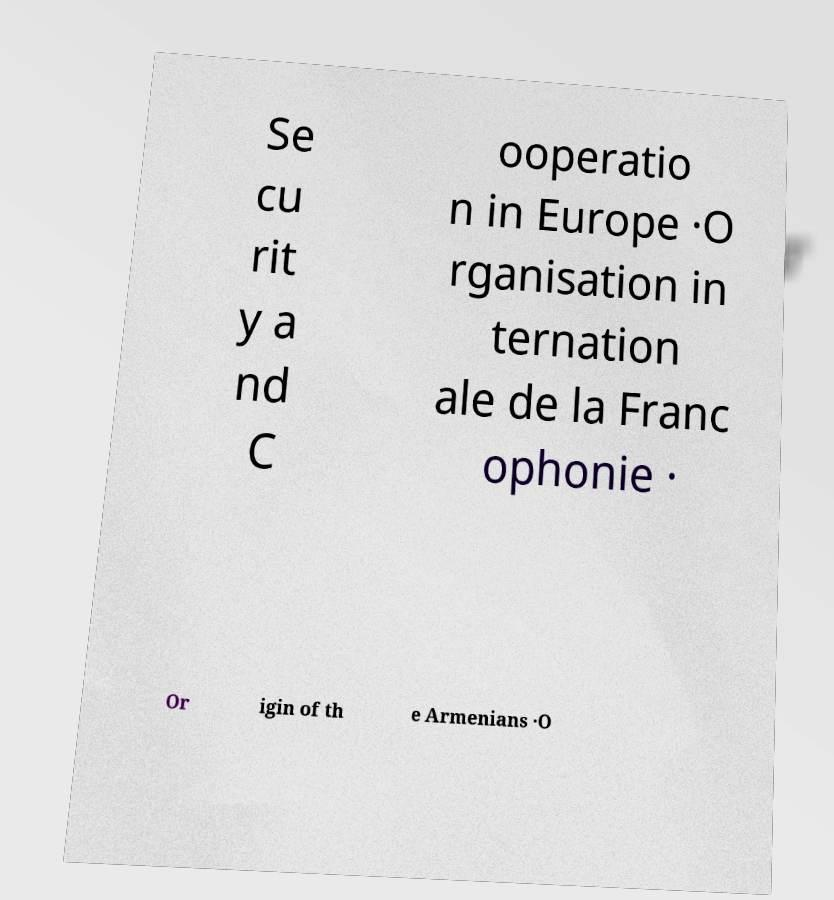Could you assist in decoding the text presented in this image and type it out clearly? Se cu rit y a nd C ooperatio n in Europe ·O rganisation in ternation ale de la Franc ophonie · Or igin of th e Armenians ·O 